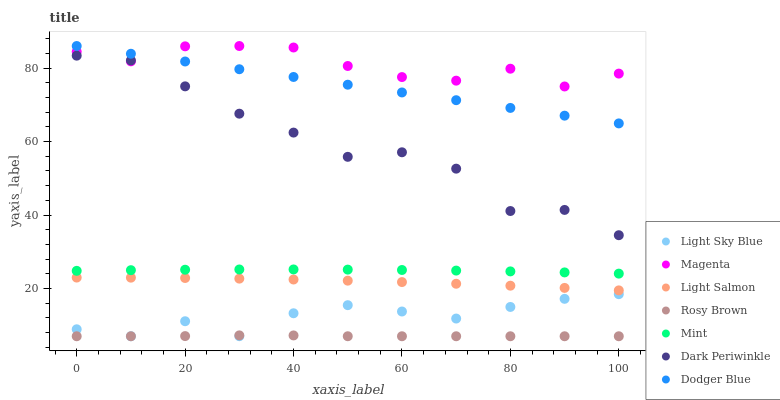Does Rosy Brown have the minimum area under the curve?
Answer yes or no. Yes. Does Magenta have the maximum area under the curve?
Answer yes or no. Yes. Does Light Sky Blue have the minimum area under the curve?
Answer yes or no. No. Does Light Sky Blue have the maximum area under the curve?
Answer yes or no. No. Is Dodger Blue the smoothest?
Answer yes or no. Yes. Is Dark Periwinkle the roughest?
Answer yes or no. Yes. Is Rosy Brown the smoothest?
Answer yes or no. No. Is Rosy Brown the roughest?
Answer yes or no. No. Does Rosy Brown have the lowest value?
Answer yes or no. Yes. Does Dodger Blue have the lowest value?
Answer yes or no. No. Does Magenta have the highest value?
Answer yes or no. Yes. Does Light Sky Blue have the highest value?
Answer yes or no. No. Is Light Sky Blue less than Mint?
Answer yes or no. Yes. Is Magenta greater than Rosy Brown?
Answer yes or no. Yes. Does Dodger Blue intersect Magenta?
Answer yes or no. Yes. Is Dodger Blue less than Magenta?
Answer yes or no. No. Is Dodger Blue greater than Magenta?
Answer yes or no. No. Does Light Sky Blue intersect Mint?
Answer yes or no. No. 